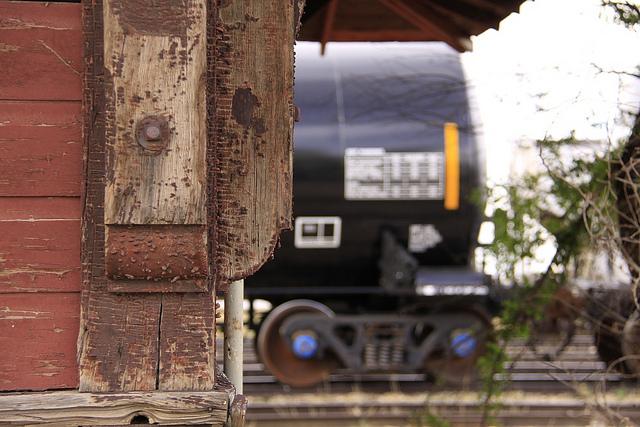Is this a passenger train or a freight train?
Concise answer only. Freight. Why isn't the background in focus?
Quick response, please. Close up picture. What color is the tank?
Short answer required. Black. Is it spring time?
Quick response, please. Yes. 